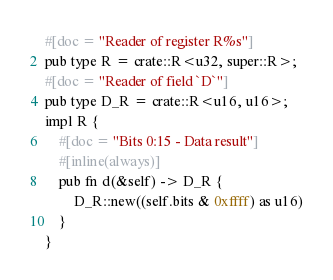Convert code to text. <code><loc_0><loc_0><loc_500><loc_500><_Rust_>#[doc = "Reader of register R%s"]
pub type R = crate::R<u32, super::R>;
#[doc = "Reader of field `D`"]
pub type D_R = crate::R<u16, u16>;
impl R {
    #[doc = "Bits 0:15 - Data result"]
    #[inline(always)]
    pub fn d(&self) -> D_R {
        D_R::new((self.bits & 0xffff) as u16)
    }
}
</code> 